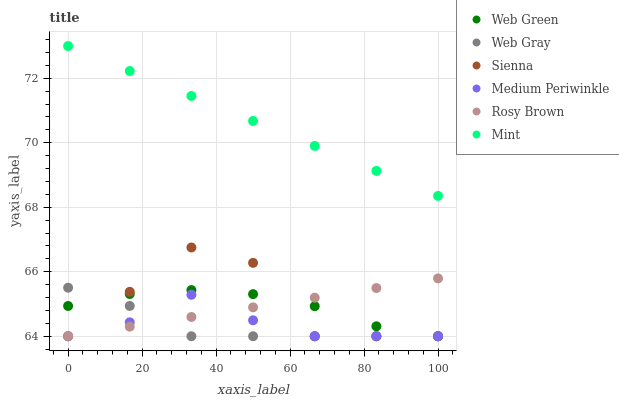Does Web Gray have the minimum area under the curve?
Answer yes or no. Yes. Does Mint have the maximum area under the curve?
Answer yes or no. Yes. Does Rosy Brown have the minimum area under the curve?
Answer yes or no. No. Does Rosy Brown have the maximum area under the curve?
Answer yes or no. No. Is Mint the smoothest?
Answer yes or no. Yes. Is Sienna the roughest?
Answer yes or no. Yes. Is Rosy Brown the smoothest?
Answer yes or no. No. Is Rosy Brown the roughest?
Answer yes or no. No. Does Web Gray have the lowest value?
Answer yes or no. Yes. Does Mint have the lowest value?
Answer yes or no. No. Does Mint have the highest value?
Answer yes or no. Yes. Does Rosy Brown have the highest value?
Answer yes or no. No. Is Medium Periwinkle less than Mint?
Answer yes or no. Yes. Is Mint greater than Medium Periwinkle?
Answer yes or no. Yes. Does Web Green intersect Medium Periwinkle?
Answer yes or no. Yes. Is Web Green less than Medium Periwinkle?
Answer yes or no. No. Is Web Green greater than Medium Periwinkle?
Answer yes or no. No. Does Medium Periwinkle intersect Mint?
Answer yes or no. No. 